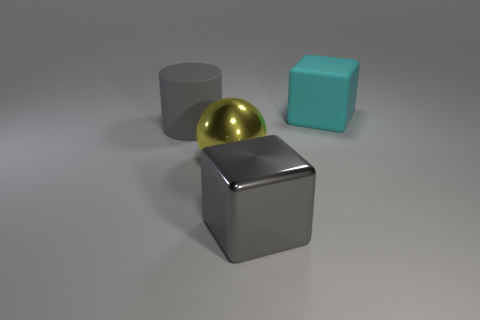What shape is the big rubber thing left of the gray cube?
Offer a terse response. Cylinder. Is the color of the large rubber thing that is left of the big yellow thing the same as the large shiny block?
Offer a very short reply. Yes. What material is the cube that is the same color as the rubber cylinder?
Give a very brief answer. Metal. There is a rubber object that is on the right side of the gray cube; is it the same size as the metallic cube?
Make the answer very short. Yes. Are there any tiny rubber spheres that have the same color as the large cylinder?
Ensure brevity in your answer.  No. There is a big thing that is to the right of the big shiny block; is there a block that is left of it?
Offer a terse response. Yes. Is there a small yellow cube made of the same material as the gray cube?
Make the answer very short. No. What is the material of the gray thing in front of the large rubber object left of the rubber block?
Ensure brevity in your answer.  Metal. What is the material of the big thing that is both in front of the big gray matte thing and on the right side of the shiny sphere?
Offer a terse response. Metal. Is the number of gray matte cylinders behind the big gray cylinder the same as the number of big purple rubber blocks?
Give a very brief answer. Yes. 